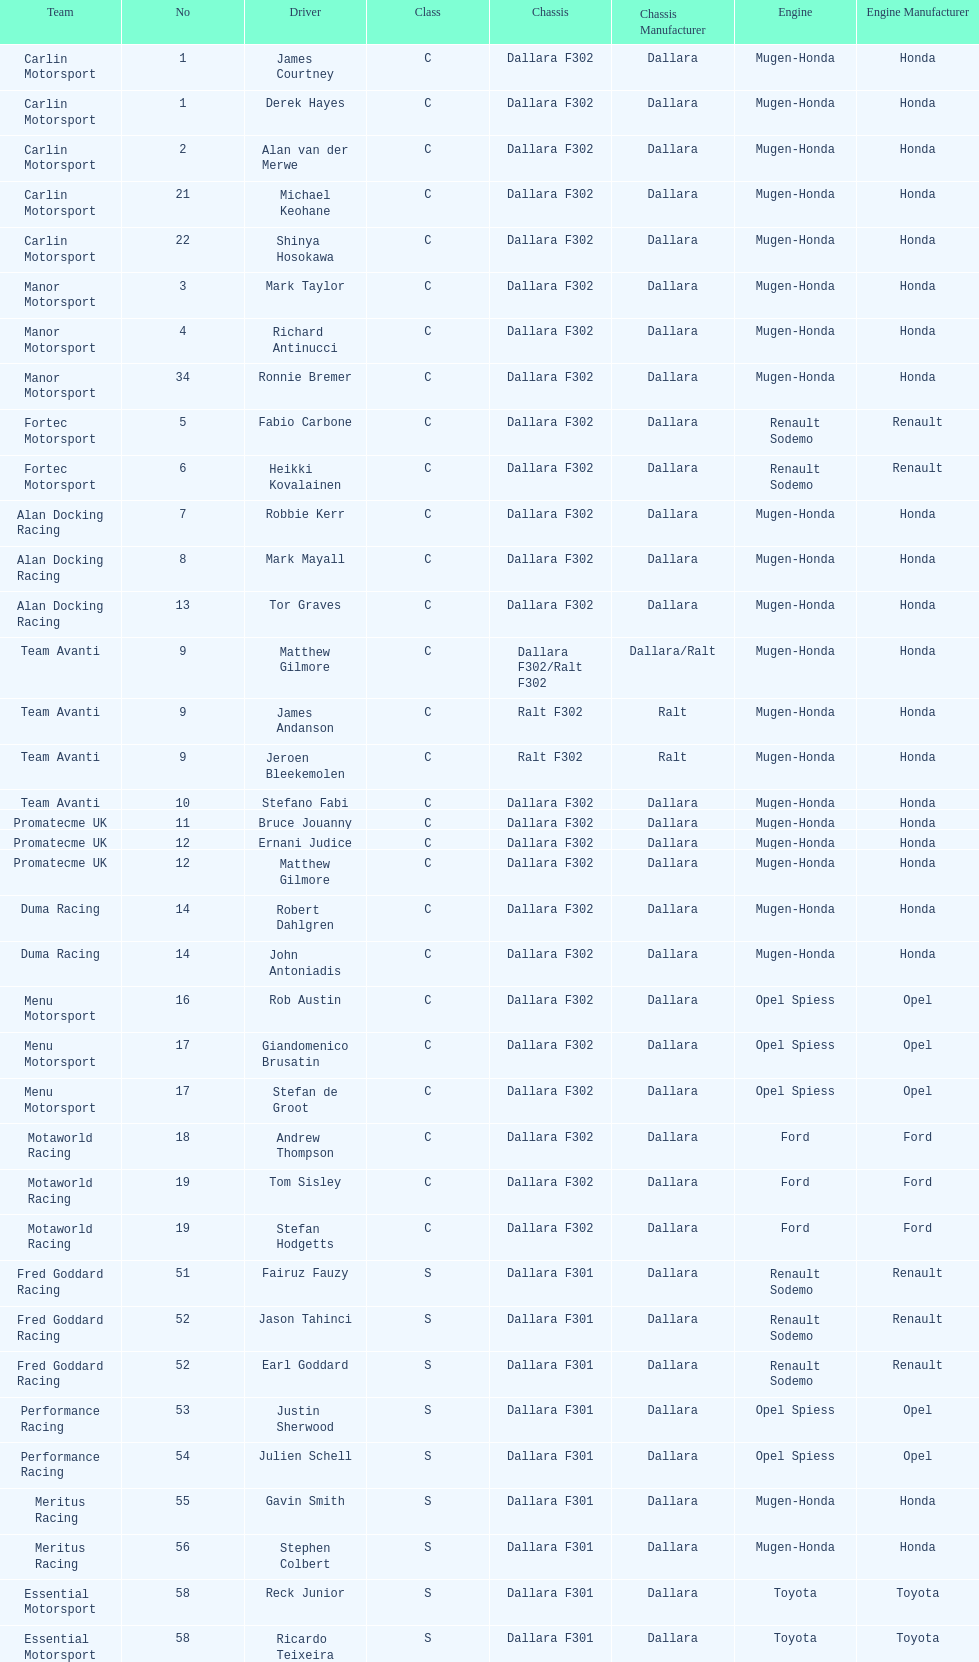How many class s (scholarship) teams are on the chart? 19. 